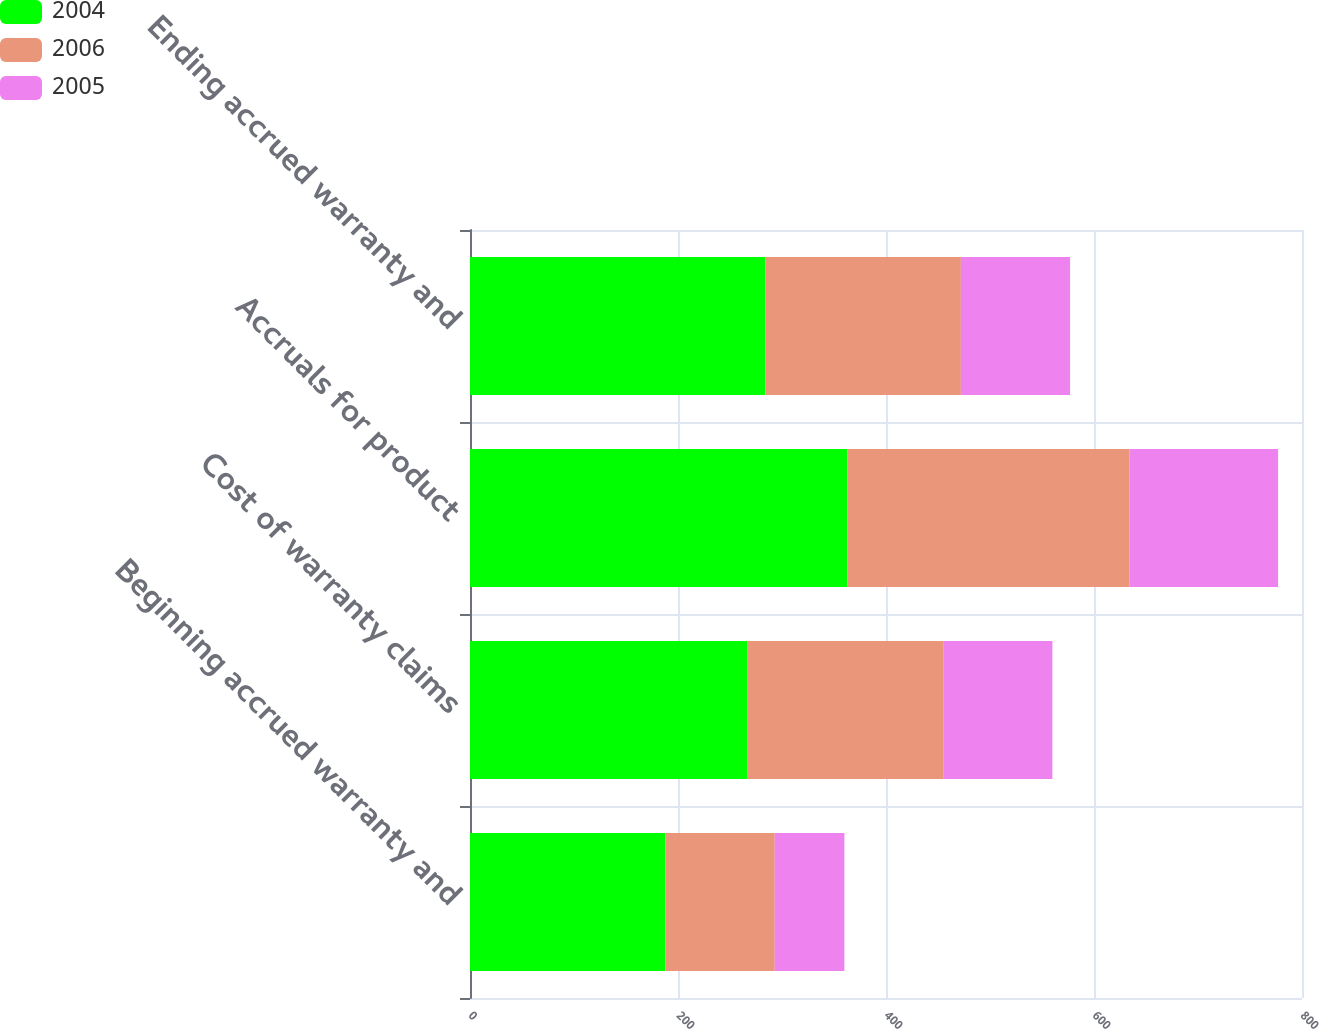Convert chart. <chart><loc_0><loc_0><loc_500><loc_500><stacked_bar_chart><ecel><fcel>Beginning accrued warranty and<fcel>Cost of warranty claims<fcel>Accruals for product<fcel>Ending accrued warranty and<nl><fcel>2004<fcel>188<fcel>267<fcel>363<fcel>284<nl><fcel>2006<fcel>105<fcel>188<fcel>271<fcel>188<nl><fcel>2005<fcel>67<fcel>105<fcel>143<fcel>105<nl></chart> 